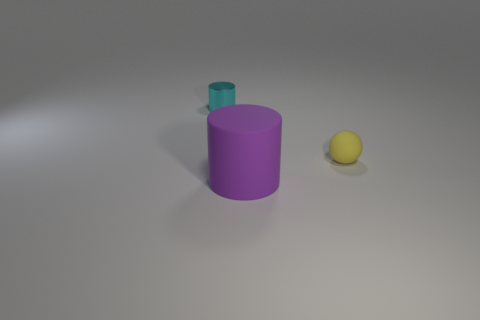Add 1 yellow objects. How many objects exist? 4 Subtract all cylinders. How many objects are left? 1 Subtract 0 blue cylinders. How many objects are left? 3 Subtract all spheres. Subtract all brown things. How many objects are left? 2 Add 3 large purple matte cylinders. How many large purple matte cylinders are left? 4 Add 1 large yellow metal cylinders. How many large yellow metal cylinders exist? 1 